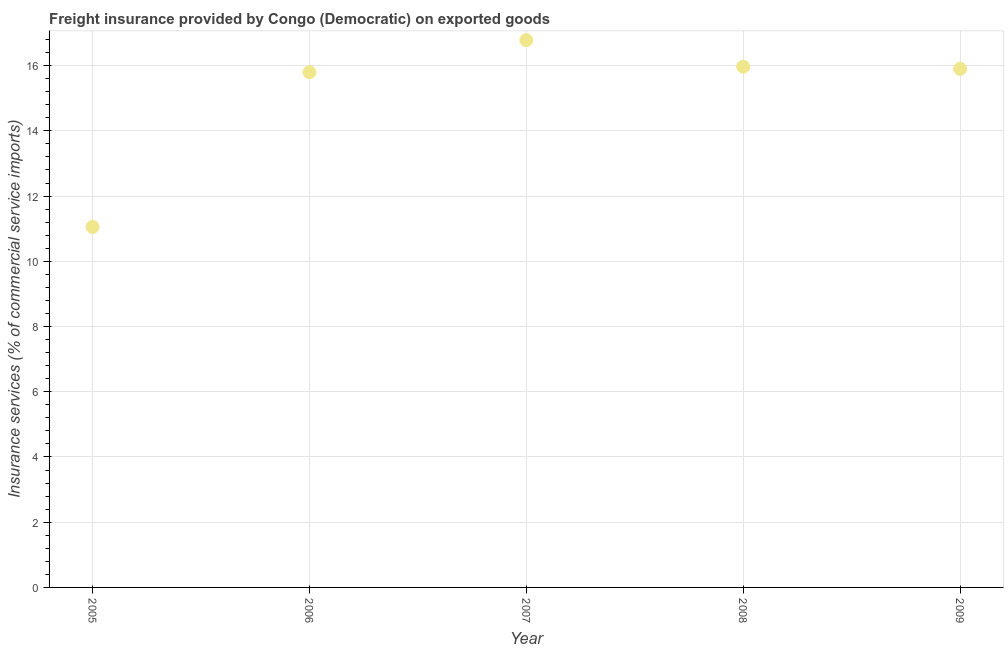What is the freight insurance in 2006?
Make the answer very short. 15.8. Across all years, what is the maximum freight insurance?
Keep it short and to the point. 16.78. Across all years, what is the minimum freight insurance?
Provide a short and direct response. 11.05. In which year was the freight insurance minimum?
Offer a very short reply. 2005. What is the sum of the freight insurance?
Keep it short and to the point. 75.5. What is the difference between the freight insurance in 2008 and 2009?
Provide a succinct answer. 0.06. What is the average freight insurance per year?
Your response must be concise. 15.1. What is the median freight insurance?
Your response must be concise. 15.9. Do a majority of the years between 2006 and 2005 (inclusive) have freight insurance greater than 8.4 %?
Your answer should be compact. No. What is the ratio of the freight insurance in 2005 to that in 2008?
Give a very brief answer. 0.69. Is the freight insurance in 2007 less than that in 2008?
Keep it short and to the point. No. Is the difference between the freight insurance in 2005 and 2007 greater than the difference between any two years?
Keep it short and to the point. Yes. What is the difference between the highest and the second highest freight insurance?
Offer a very short reply. 0.81. What is the difference between the highest and the lowest freight insurance?
Offer a very short reply. 5.73. How many years are there in the graph?
Keep it short and to the point. 5. What is the difference between two consecutive major ticks on the Y-axis?
Keep it short and to the point. 2. Are the values on the major ticks of Y-axis written in scientific E-notation?
Make the answer very short. No. Does the graph contain grids?
Make the answer very short. Yes. What is the title of the graph?
Keep it short and to the point. Freight insurance provided by Congo (Democratic) on exported goods . What is the label or title of the Y-axis?
Offer a very short reply. Insurance services (% of commercial service imports). What is the Insurance services (% of commercial service imports) in 2005?
Provide a short and direct response. 11.05. What is the Insurance services (% of commercial service imports) in 2006?
Ensure brevity in your answer.  15.8. What is the Insurance services (% of commercial service imports) in 2007?
Offer a terse response. 16.78. What is the Insurance services (% of commercial service imports) in 2008?
Give a very brief answer. 15.97. What is the Insurance services (% of commercial service imports) in 2009?
Your answer should be compact. 15.9. What is the difference between the Insurance services (% of commercial service imports) in 2005 and 2006?
Provide a short and direct response. -4.74. What is the difference between the Insurance services (% of commercial service imports) in 2005 and 2007?
Offer a very short reply. -5.73. What is the difference between the Insurance services (% of commercial service imports) in 2005 and 2008?
Your response must be concise. -4.91. What is the difference between the Insurance services (% of commercial service imports) in 2005 and 2009?
Provide a short and direct response. -4.85. What is the difference between the Insurance services (% of commercial service imports) in 2006 and 2007?
Your answer should be compact. -0.98. What is the difference between the Insurance services (% of commercial service imports) in 2006 and 2008?
Keep it short and to the point. -0.17. What is the difference between the Insurance services (% of commercial service imports) in 2006 and 2009?
Keep it short and to the point. -0.1. What is the difference between the Insurance services (% of commercial service imports) in 2007 and 2008?
Your answer should be compact. 0.81. What is the difference between the Insurance services (% of commercial service imports) in 2007 and 2009?
Your answer should be very brief. 0.88. What is the difference between the Insurance services (% of commercial service imports) in 2008 and 2009?
Offer a terse response. 0.06. What is the ratio of the Insurance services (% of commercial service imports) in 2005 to that in 2006?
Keep it short and to the point. 0.7. What is the ratio of the Insurance services (% of commercial service imports) in 2005 to that in 2007?
Give a very brief answer. 0.66. What is the ratio of the Insurance services (% of commercial service imports) in 2005 to that in 2008?
Give a very brief answer. 0.69. What is the ratio of the Insurance services (% of commercial service imports) in 2005 to that in 2009?
Your response must be concise. 0.69. What is the ratio of the Insurance services (% of commercial service imports) in 2006 to that in 2007?
Give a very brief answer. 0.94. What is the ratio of the Insurance services (% of commercial service imports) in 2006 to that in 2009?
Offer a very short reply. 0.99. What is the ratio of the Insurance services (% of commercial service imports) in 2007 to that in 2008?
Give a very brief answer. 1.05. What is the ratio of the Insurance services (% of commercial service imports) in 2007 to that in 2009?
Offer a very short reply. 1.05. 